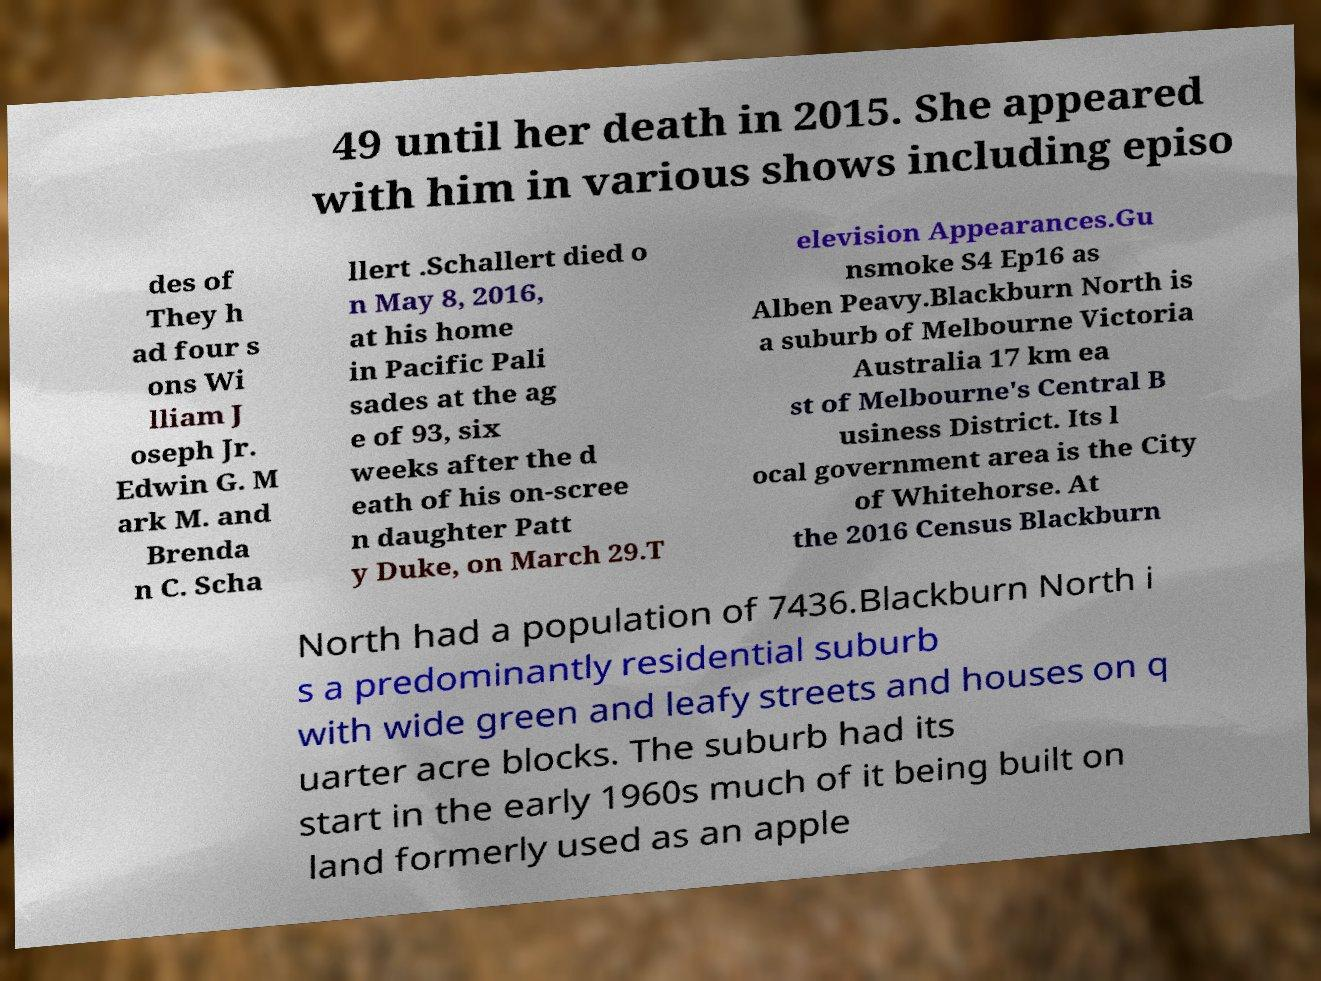Could you extract and type out the text from this image? 49 until her death in 2015. She appeared with him in various shows including episo des of They h ad four s ons Wi lliam J oseph Jr. Edwin G. M ark M. and Brenda n C. Scha llert .Schallert died o n May 8, 2016, at his home in Pacific Pali sades at the ag e of 93, six weeks after the d eath of his on-scree n daughter Patt y Duke, on March 29.T elevision Appearances.Gu nsmoke S4 Ep16 as Alben Peavy.Blackburn North is a suburb of Melbourne Victoria Australia 17 km ea st of Melbourne's Central B usiness District. Its l ocal government area is the City of Whitehorse. At the 2016 Census Blackburn North had a population of 7436.Blackburn North i s a predominantly residential suburb with wide green and leafy streets and houses on q uarter acre blocks. The suburb had its start in the early 1960s much of it being built on land formerly used as an apple 